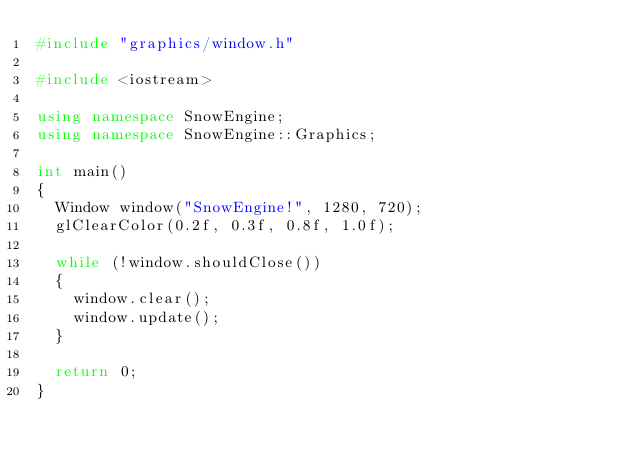Convert code to text. <code><loc_0><loc_0><loc_500><loc_500><_C++_>#include "graphics/window.h"

#include <iostream>

using namespace SnowEngine;
using namespace SnowEngine::Graphics;

int main()
{
	Window window("SnowEngine!", 1280, 720);
	glClearColor(0.2f, 0.3f, 0.8f, 1.0f);

	while (!window.shouldClose())
	{
		window.clear();
		window.update();
	}

	return 0;
}</code> 